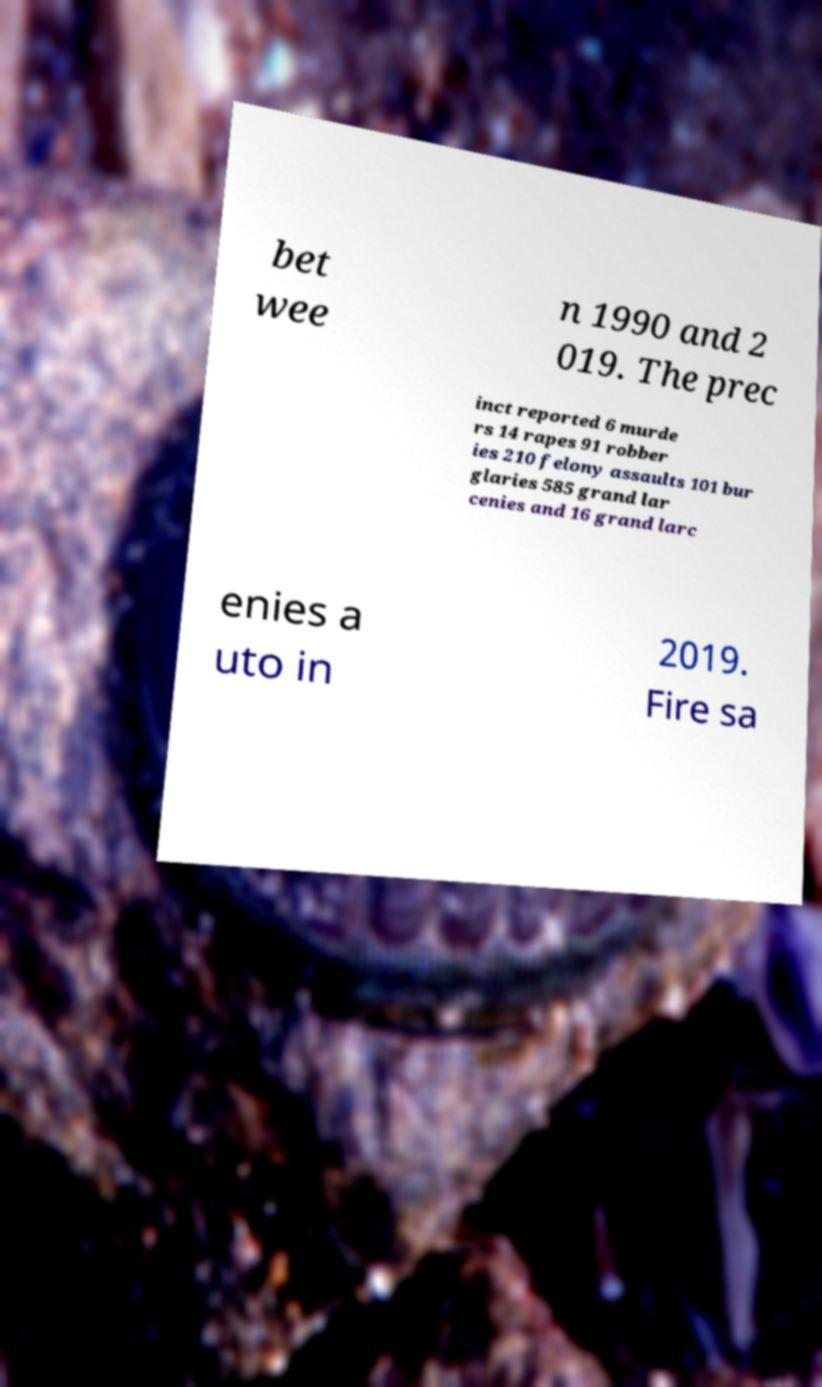There's text embedded in this image that I need extracted. Can you transcribe it verbatim? bet wee n 1990 and 2 019. The prec inct reported 6 murde rs 14 rapes 91 robber ies 210 felony assaults 101 bur glaries 585 grand lar cenies and 16 grand larc enies a uto in 2019. Fire sa 